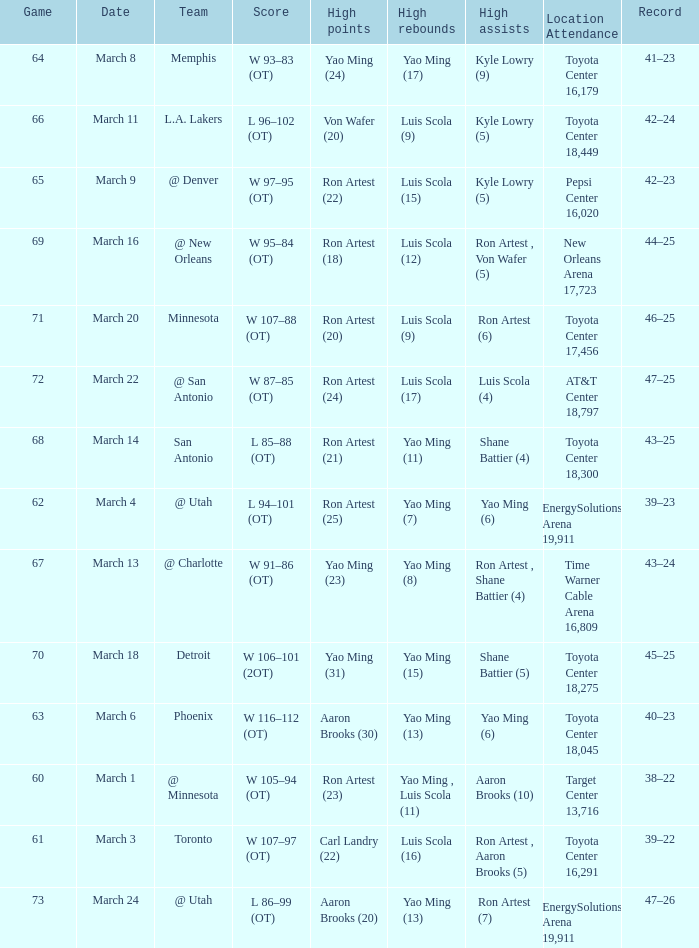On what date did the Rockets play Memphis? March 8. 